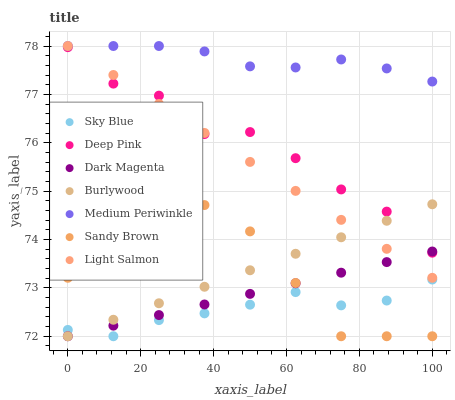Does Sky Blue have the minimum area under the curve?
Answer yes or no. Yes. Does Medium Periwinkle have the maximum area under the curve?
Answer yes or no. Yes. Does Deep Pink have the minimum area under the curve?
Answer yes or no. No. Does Deep Pink have the maximum area under the curve?
Answer yes or no. No. Is Light Salmon the smoothest?
Answer yes or no. Yes. Is Sandy Brown the roughest?
Answer yes or no. Yes. Is Deep Pink the smoothest?
Answer yes or no. No. Is Deep Pink the roughest?
Answer yes or no. No. Does Dark Magenta have the lowest value?
Answer yes or no. Yes. Does Deep Pink have the lowest value?
Answer yes or no. No. Does Medium Periwinkle have the highest value?
Answer yes or no. Yes. Does Deep Pink have the highest value?
Answer yes or no. No. Is Sandy Brown less than Medium Periwinkle?
Answer yes or no. Yes. Is Deep Pink greater than Sandy Brown?
Answer yes or no. Yes. Does Sandy Brown intersect Sky Blue?
Answer yes or no. Yes. Is Sandy Brown less than Sky Blue?
Answer yes or no. No. Is Sandy Brown greater than Sky Blue?
Answer yes or no. No. Does Sandy Brown intersect Medium Periwinkle?
Answer yes or no. No. 